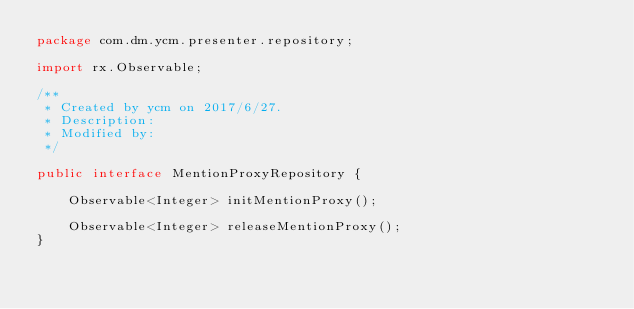Convert code to text. <code><loc_0><loc_0><loc_500><loc_500><_Java_>package com.dm.ycm.presenter.repository;

import rx.Observable;

/**
 * Created by ycm on 2017/6/27.
 * Description:
 * Modified by:
 */

public interface MentionProxyRepository {

    Observable<Integer> initMentionProxy();

    Observable<Integer> releaseMentionProxy();
}
</code> 